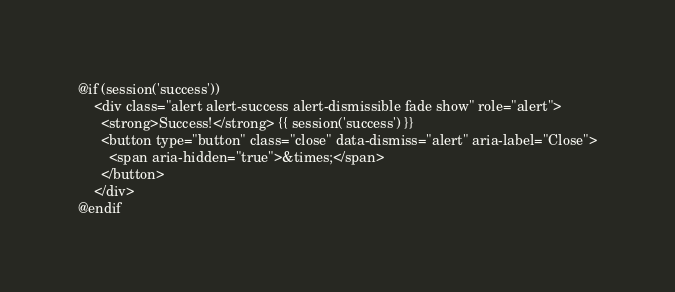<code> <loc_0><loc_0><loc_500><loc_500><_PHP_>@if (session('success'))
    <div class="alert alert-success alert-dismissible fade show" role="alert">
      <strong>Success!</strong> {{ session('success') }}
      <button type="button" class="close" data-dismiss="alert" aria-label="Close">
        <span aria-hidden="true">&times;</span>
      </button>
    </div>
@endif</code> 